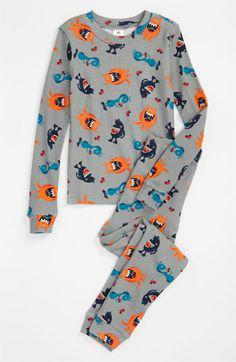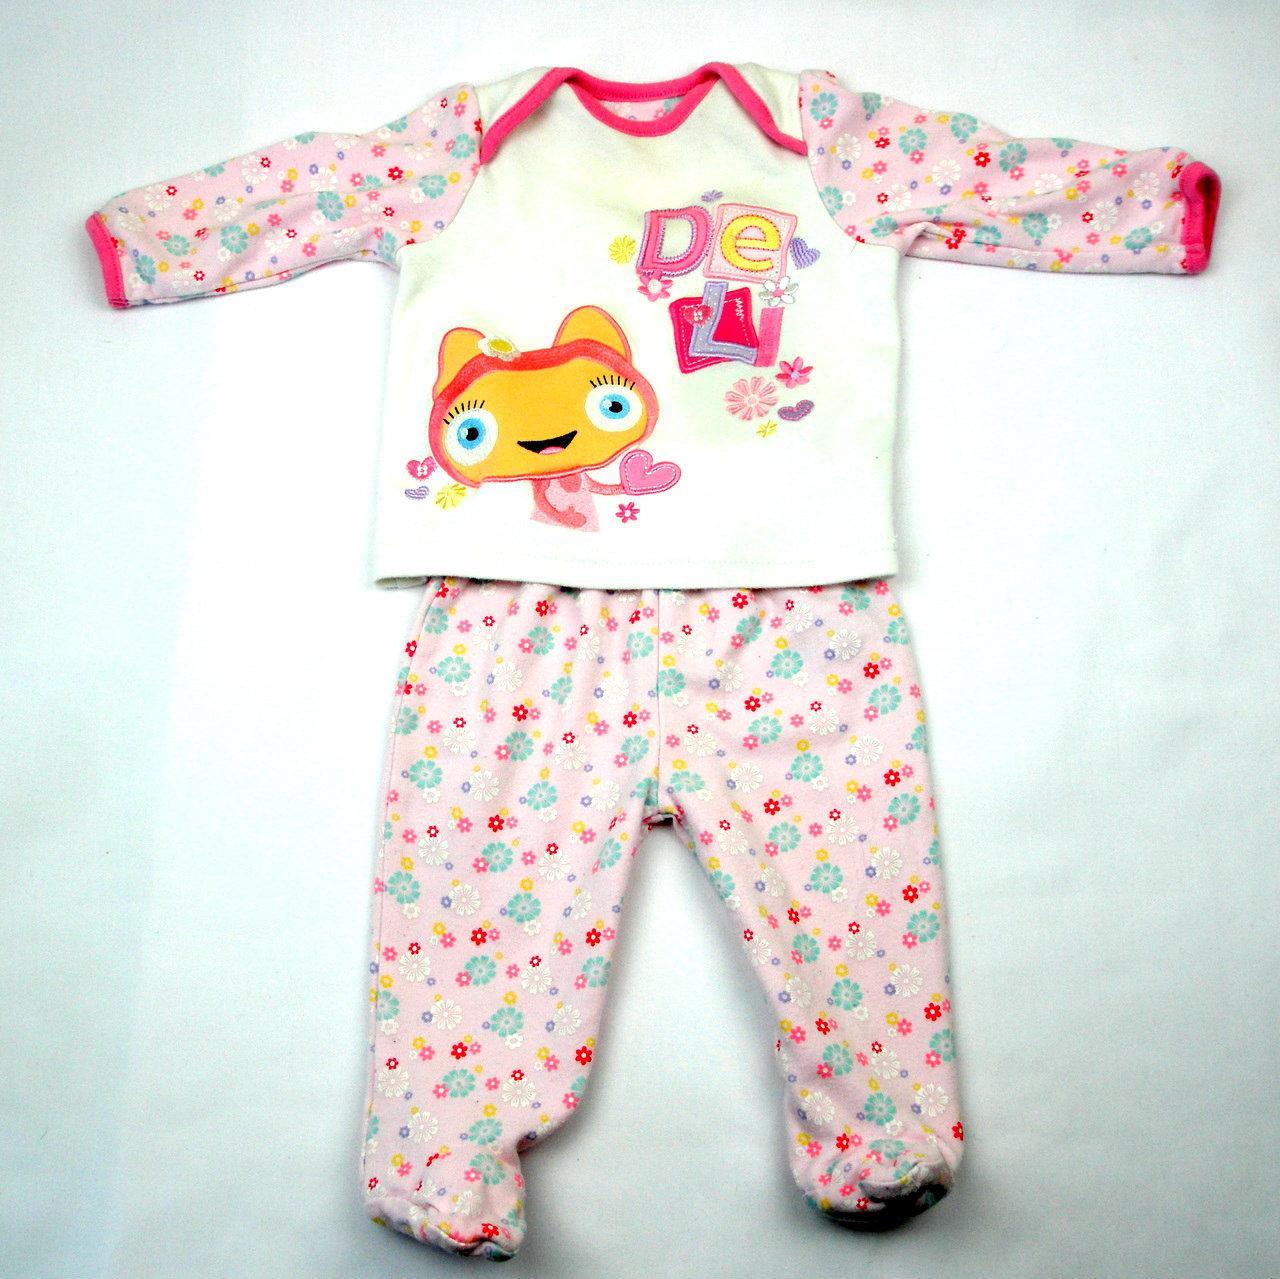The first image is the image on the left, the second image is the image on the right. Given the left and right images, does the statement "A pajama set with an overall print design has wide cuffs on its long pants and long sleeved shirt, and a rounded collar on the shirt." hold true? Answer yes or no. Yes. 